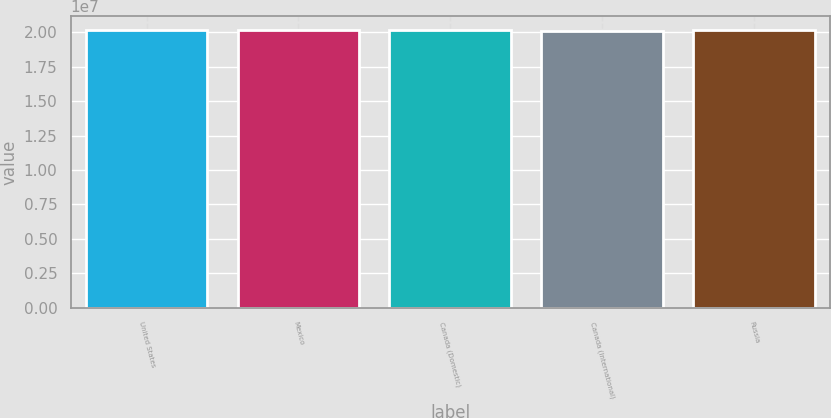<chart> <loc_0><loc_0><loc_500><loc_500><bar_chart><fcel>United States<fcel>Mexico<fcel>Canada (Domestic)<fcel>Canada (International)<fcel>Russia<nl><fcel>2.0122e+07<fcel>2.0142e+07<fcel>2.0132e+07<fcel>2.0102e+07<fcel>2.0126e+07<nl></chart> 